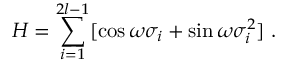Convert formula to latex. <formula><loc_0><loc_0><loc_500><loc_500>H = \sum _ { i = 1 } ^ { 2 l - 1 } [ \cos \omega \sigma _ { i } + \sin \omega \sigma _ { i } ^ { 2 } ] \, .</formula> 